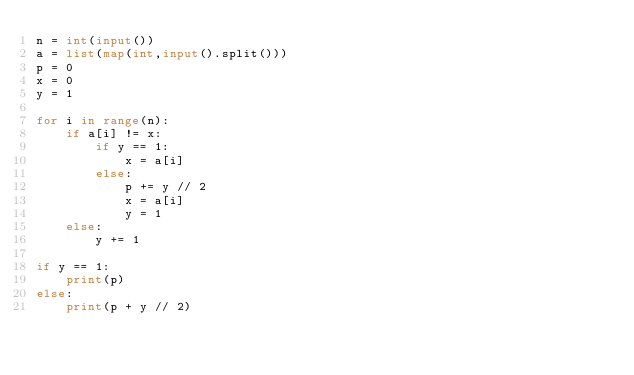<code> <loc_0><loc_0><loc_500><loc_500><_Python_>n = int(input())
a = list(map(int,input().split()))
p = 0
x = 0
y = 1

for i in range(n):
    if a[i] != x:
        if y == 1:
            x = a[i]
        else:
            p += y // 2
            x = a[i]
            y = 1
    else:
        y += 1

if y == 1:
    print(p)
else:
    print(p + y // 2)</code> 